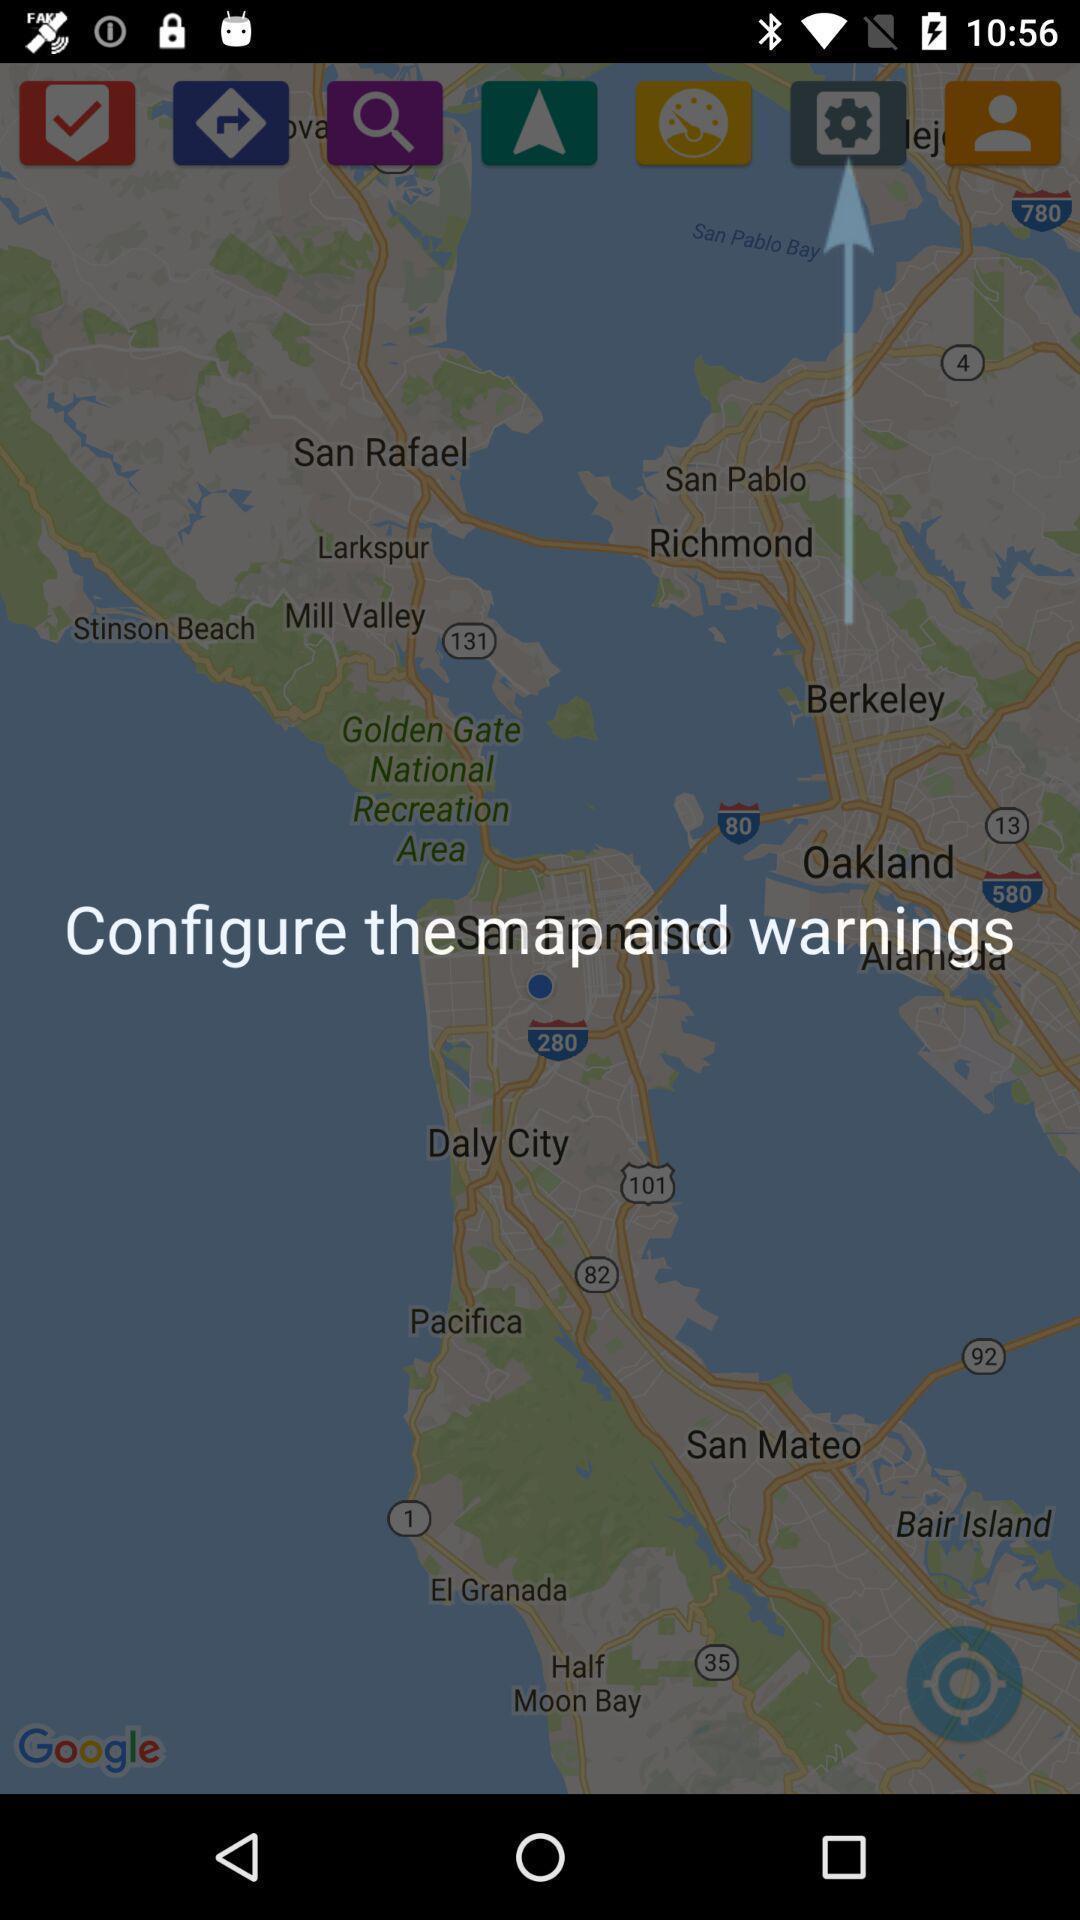Tell me what you see in this picture. Pop-up screen displaying the use of the features. 